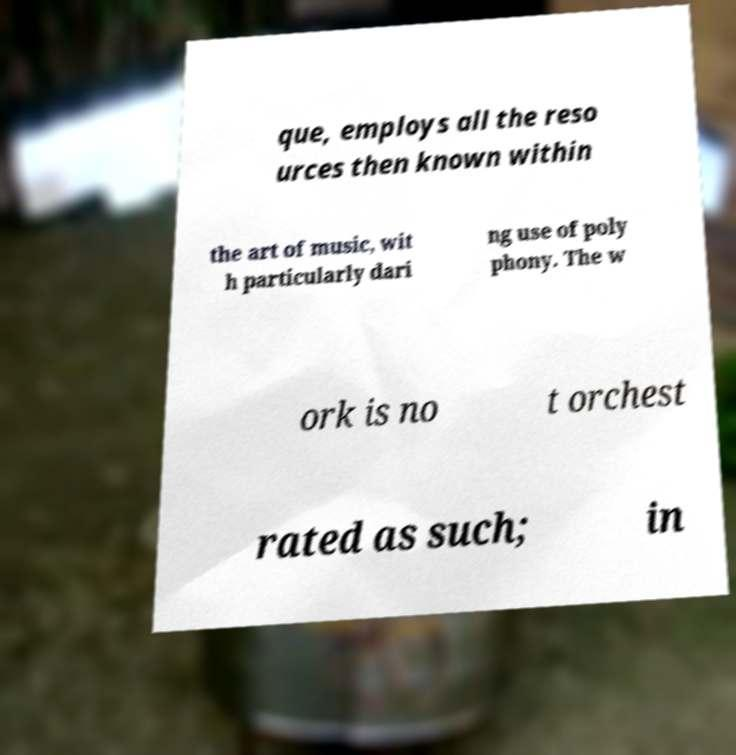Could you assist in decoding the text presented in this image and type it out clearly? que, employs all the reso urces then known within the art of music, wit h particularly dari ng use of poly phony. The w ork is no t orchest rated as such; in 